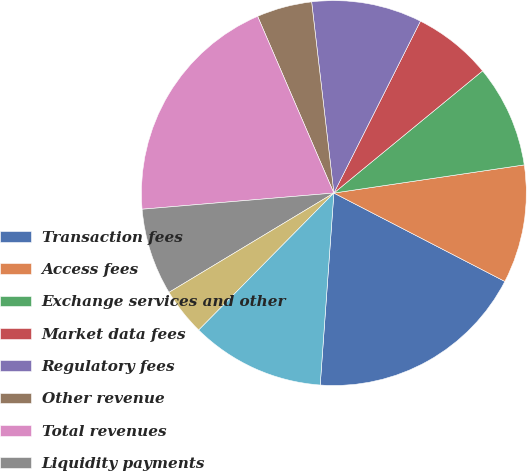Convert chart. <chart><loc_0><loc_0><loc_500><loc_500><pie_chart><fcel>Transaction fees<fcel>Access fees<fcel>Exchange services and other<fcel>Market data fees<fcel>Regulatory fees<fcel>Other revenue<fcel>Total revenues<fcel>Liquidity payments<fcel>Routing and clearing<fcel>Royalty fees<nl><fcel>18.54%<fcel>9.93%<fcel>8.61%<fcel>6.63%<fcel>9.27%<fcel>4.64%<fcel>19.86%<fcel>7.29%<fcel>3.98%<fcel>11.26%<nl></chart> 